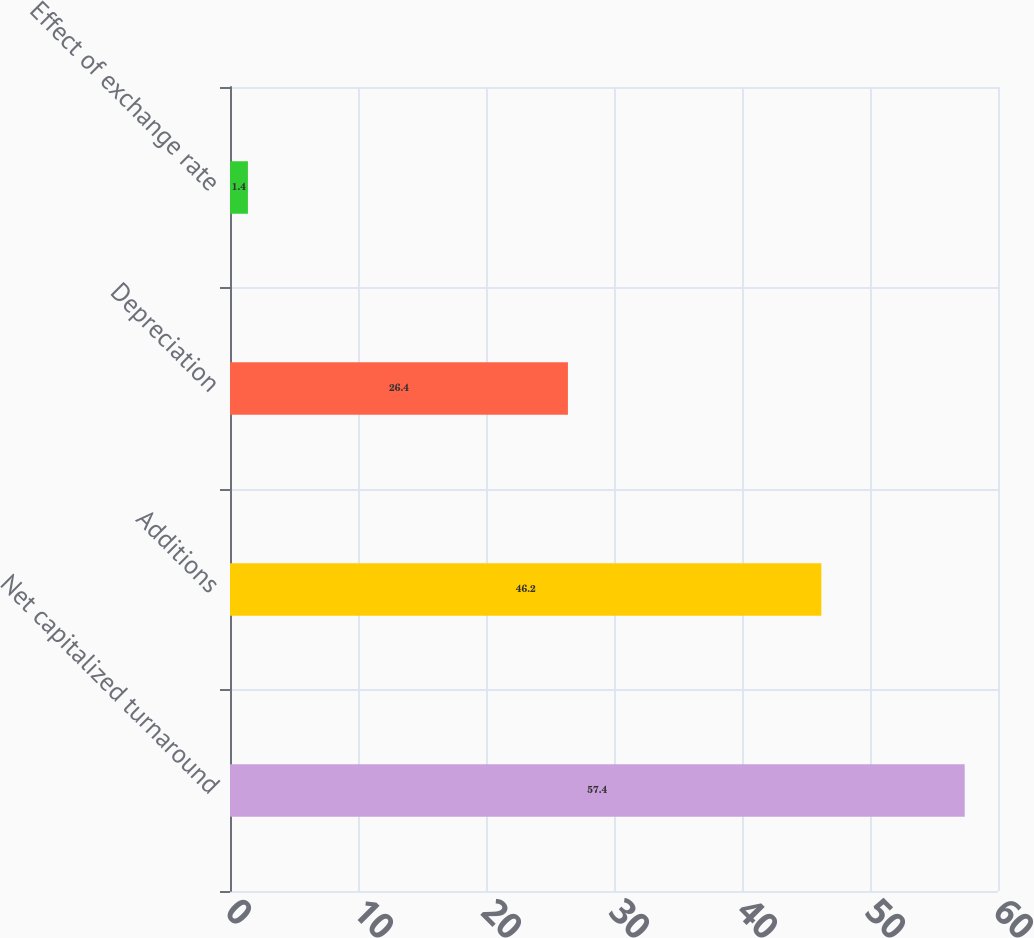<chart> <loc_0><loc_0><loc_500><loc_500><bar_chart><fcel>Net capitalized turnaround<fcel>Additions<fcel>Depreciation<fcel>Effect of exchange rate<nl><fcel>57.4<fcel>46.2<fcel>26.4<fcel>1.4<nl></chart> 